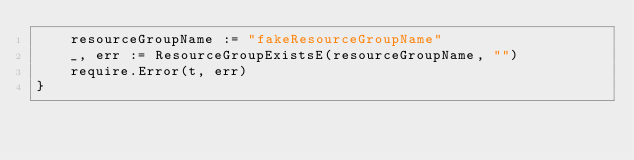Convert code to text. <code><loc_0><loc_0><loc_500><loc_500><_Go_>	resourceGroupName := "fakeResourceGroupName"
	_, err := ResourceGroupExistsE(resourceGroupName, "")
	require.Error(t, err)
}
</code> 